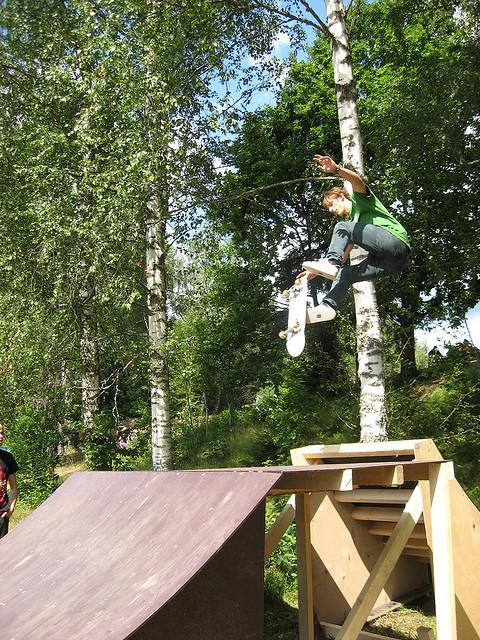What is this large contraption called? ramp 